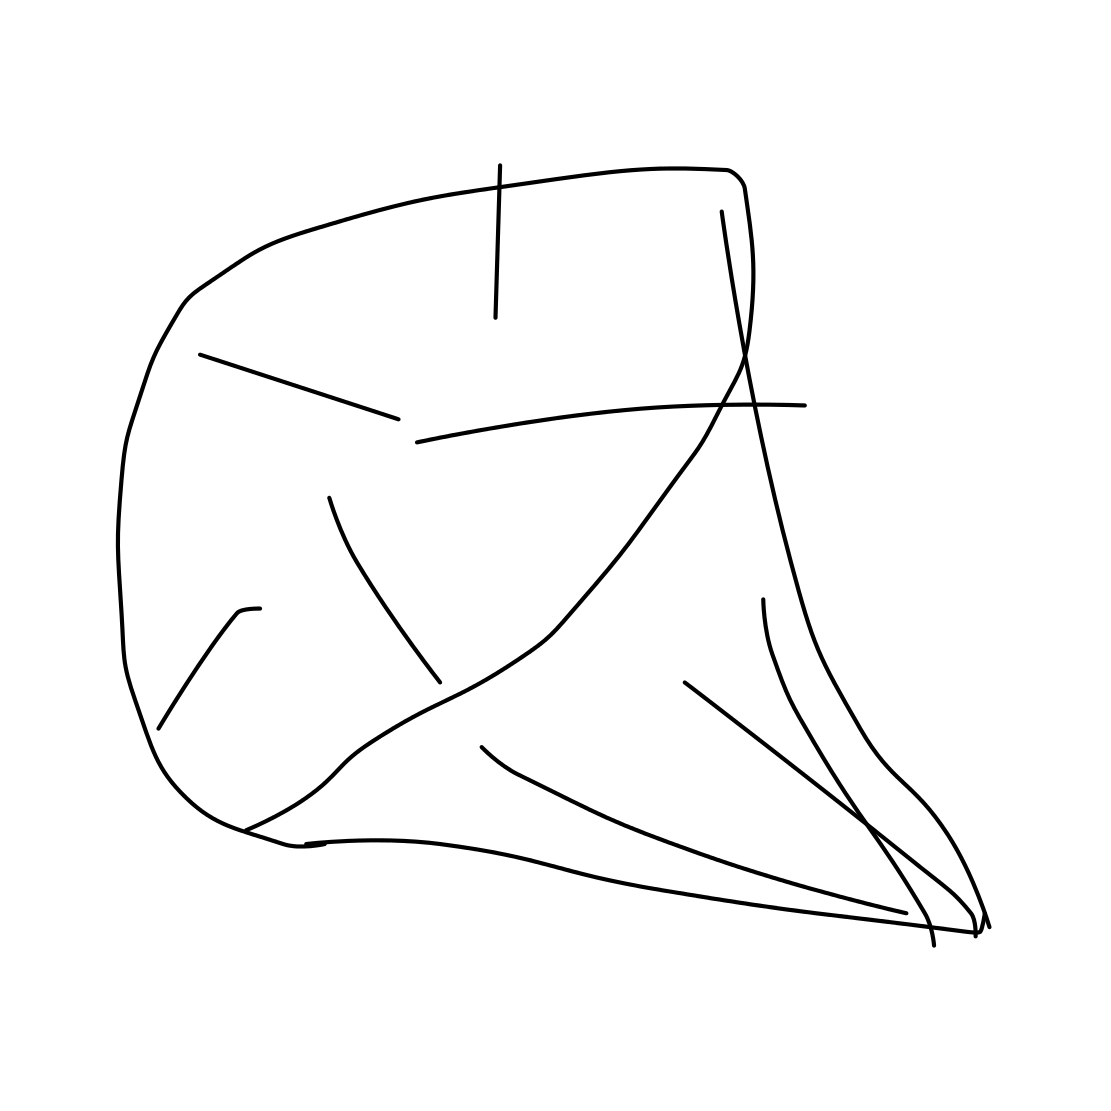What kind of shape is represented in this drawing? The drawing appears to represent an abstract form with irregular angles and lines. It could be interpreted in various ways, but it doesn't clearly resemble a specific known shape. 